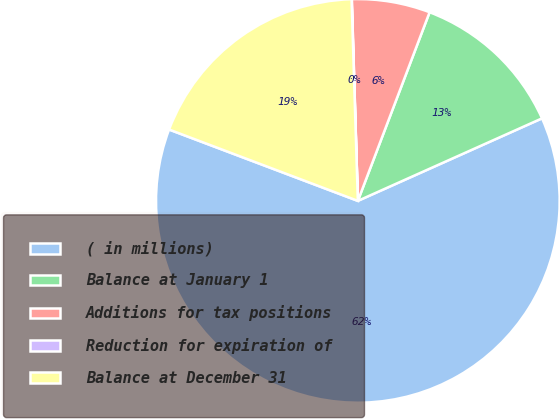Convert chart to OTSL. <chart><loc_0><loc_0><loc_500><loc_500><pie_chart><fcel>( in millions)<fcel>Balance at January 1<fcel>Additions for tax positions<fcel>Reduction for expiration of<fcel>Balance at December 31<nl><fcel>62.45%<fcel>12.51%<fcel>6.26%<fcel>0.02%<fcel>18.75%<nl></chart> 